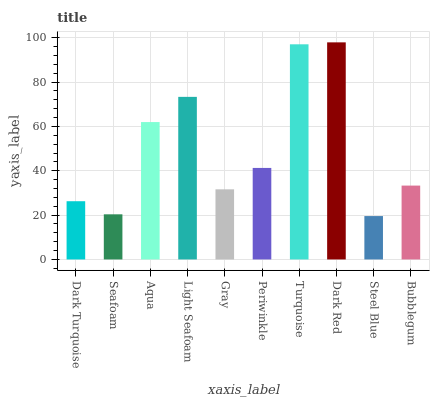Is Seafoam the minimum?
Answer yes or no. No. Is Seafoam the maximum?
Answer yes or no. No. Is Dark Turquoise greater than Seafoam?
Answer yes or no. Yes. Is Seafoam less than Dark Turquoise?
Answer yes or no. Yes. Is Seafoam greater than Dark Turquoise?
Answer yes or no. No. Is Dark Turquoise less than Seafoam?
Answer yes or no. No. Is Periwinkle the high median?
Answer yes or no. Yes. Is Bubblegum the low median?
Answer yes or no. Yes. Is Bubblegum the high median?
Answer yes or no. No. Is Gray the low median?
Answer yes or no. No. 